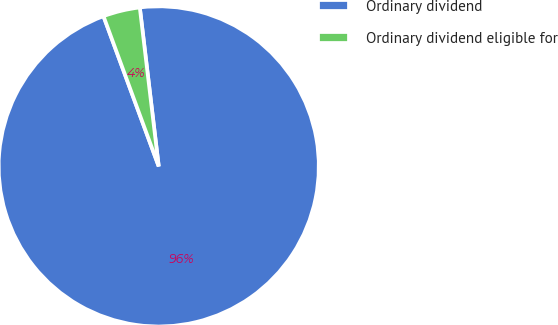Convert chart. <chart><loc_0><loc_0><loc_500><loc_500><pie_chart><fcel>Ordinary dividend<fcel>Ordinary dividend eligible for<nl><fcel>96.28%<fcel>3.72%<nl></chart> 